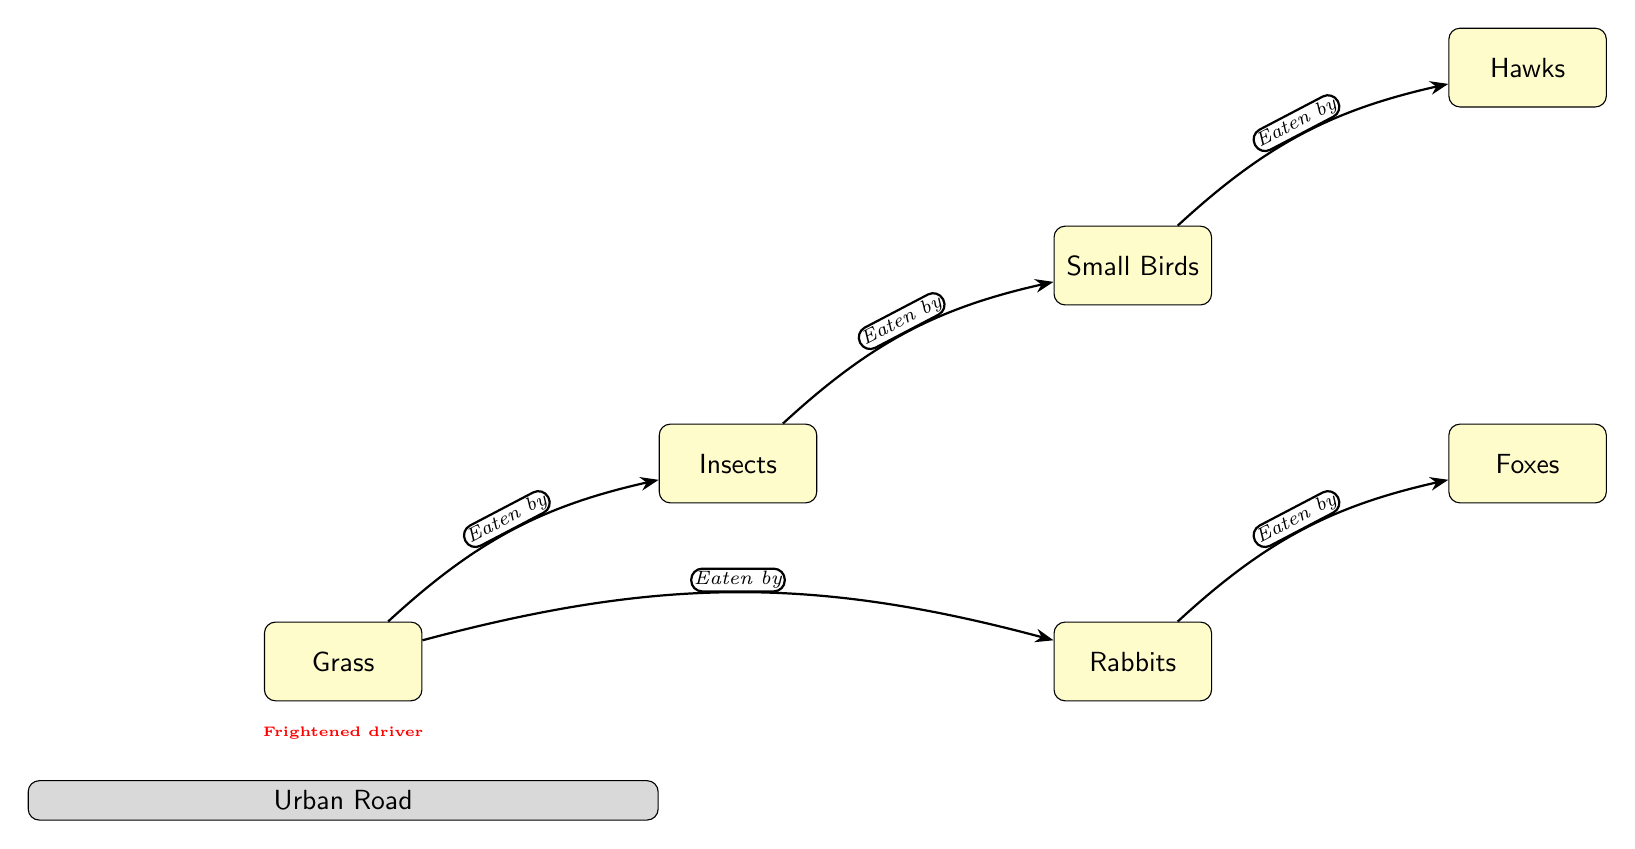What is the first organism in the food chain? The first organism in the food chain is located at the bottom of the diagram, represented as 'Grass.'
Answer: Grass How many organisms are shown in the food chain? By counting the distinct organisms listed in the diagram, there are six: Grass, Insects, Small Birds, Rabbits, Foxes, and Hawks.
Answer: 6 Which organism is preyed upon by Small Birds? The diagram shows that Insects are the only organism that Small Birds prey upon, as indicated by the directional edge connecting them.
Answer: Insects What animal is at the top of this food chain? In the diagram, Hawks are positioned at the top of the food chain, indicating they are the final predator in this local wildlife context.
Answer: Hawks Which two organisms share the same prey? In this diagram, both Rabbits and Insects consume Grass as their prey, as indicated by separate edges pointing towards Grass.
Answer: Grass How many relationships (edges) are represented in the diagram? The number of edges in the diagram can be counted: there are five distinct relationships displayed between the organisms.
Answer: 5 Which predator preys upon Rabbits? The edge in the diagram indicates that Foxes are the predators that prey upon Rabbits, as shown by the directed edge connecting them.
Answer: Foxes What lies directly below the Grass in the diagram? The diagram clearly indicates that the Urban Road is located directly below Grass, serving as a contextual reference in the environmental setting.
Answer: Urban Road How many species consume Grass? By evaluating the diagram, both Insects and Rabbits are shown to consume Grass, totaling two species that do so.
Answer: 2 Is there any organism that preys specifically on Foxes in this food chain? The diagram does not show any pathways leading from another organism preying on Foxes, indicating that they are not preyed upon in this specific food chain.
Answer: No 